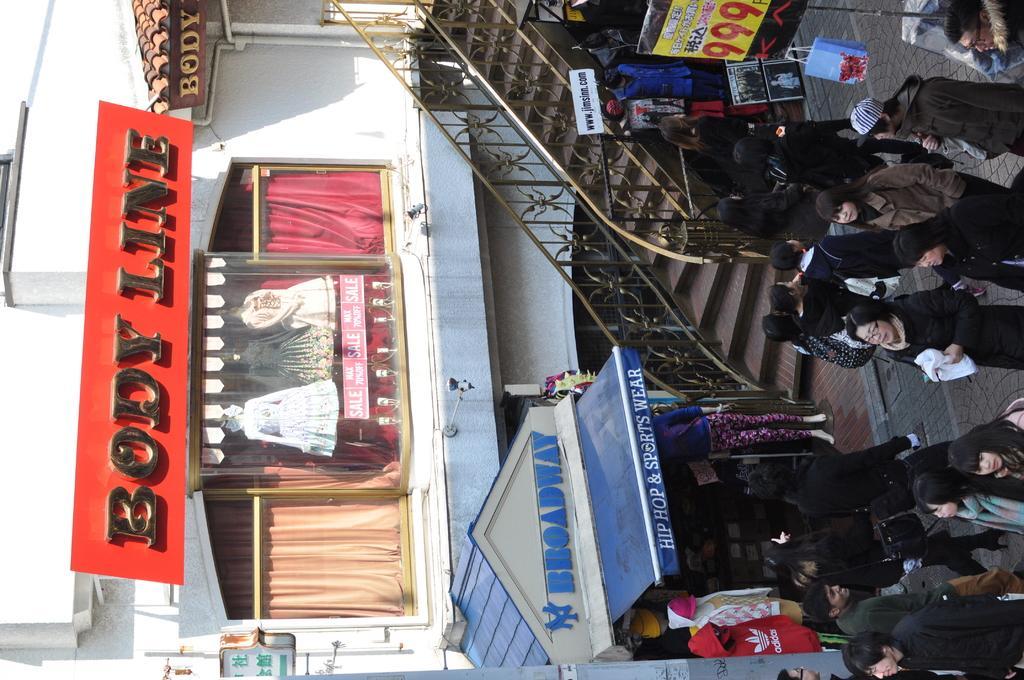In one or two sentences, can you explain what this image depicts? In the middle a building is visible of white in color in which mannequins are there in a glass. In the right there are group of people standing and walking on the road. Next to that a staircase is visible and few shops are visible in the middle bottom. And curtain is visible golden and pink in color and boards are visible. This image is taken on the road during day time. 